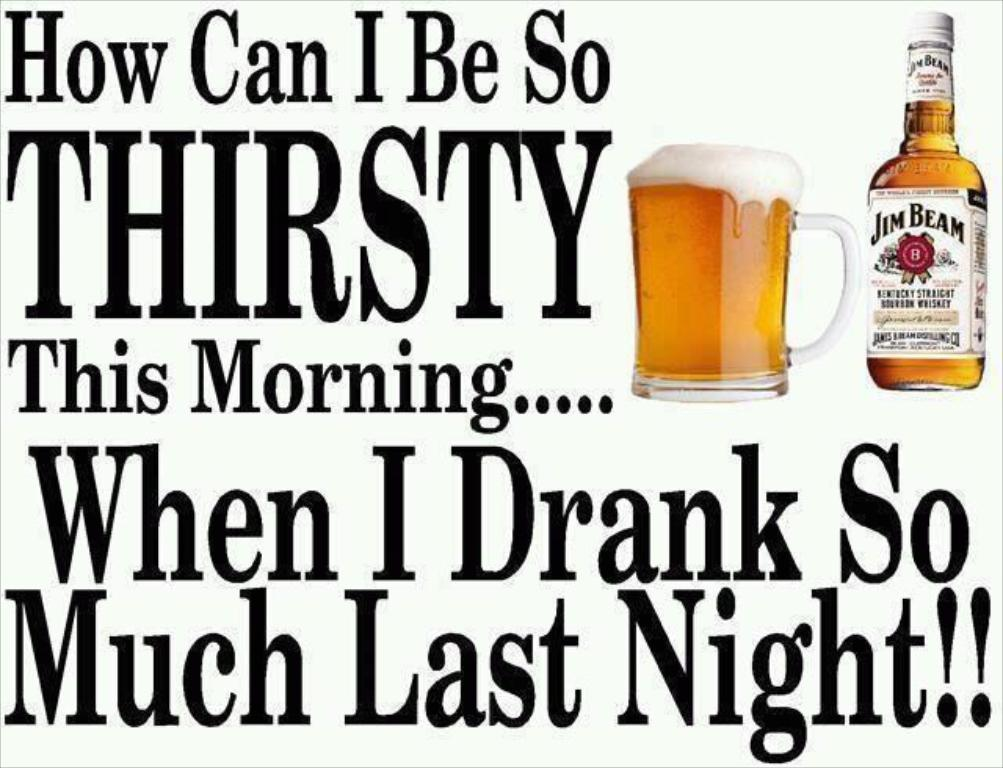<image>
Create a compact narrative representing the image presented. A bottle of Jim Beam whiskey with a full glass of whiskey beside it and a meme . 